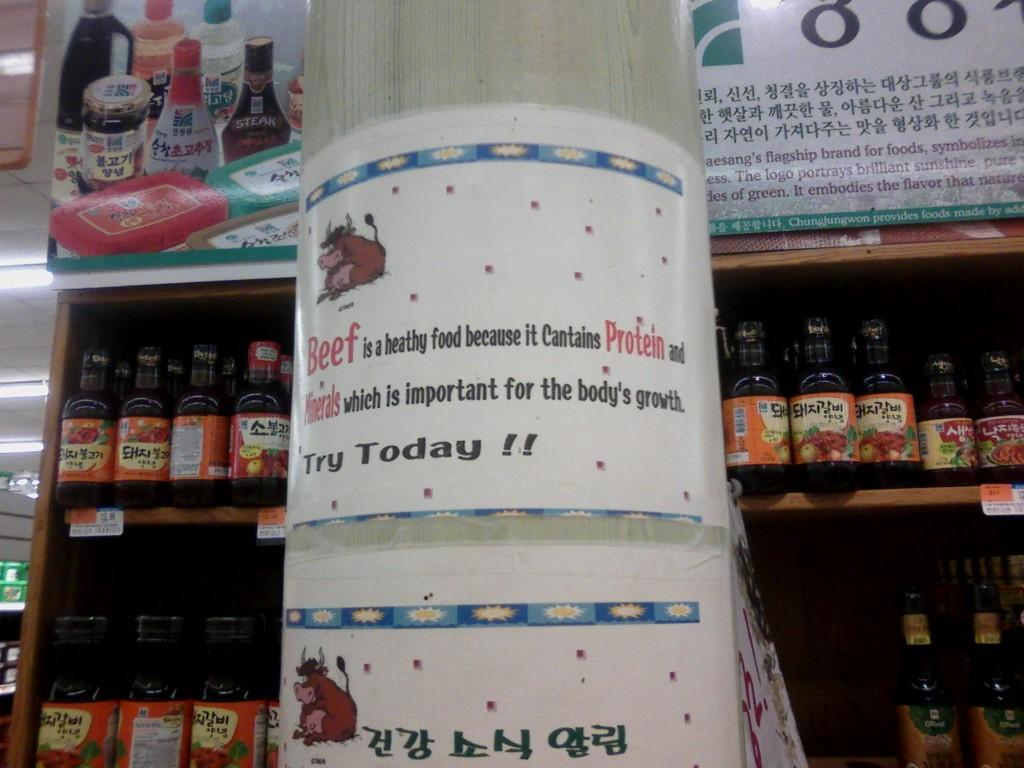<image>
Render a clear and concise summary of the photo. A flyer suggests to try today and has a picture of a cow. 